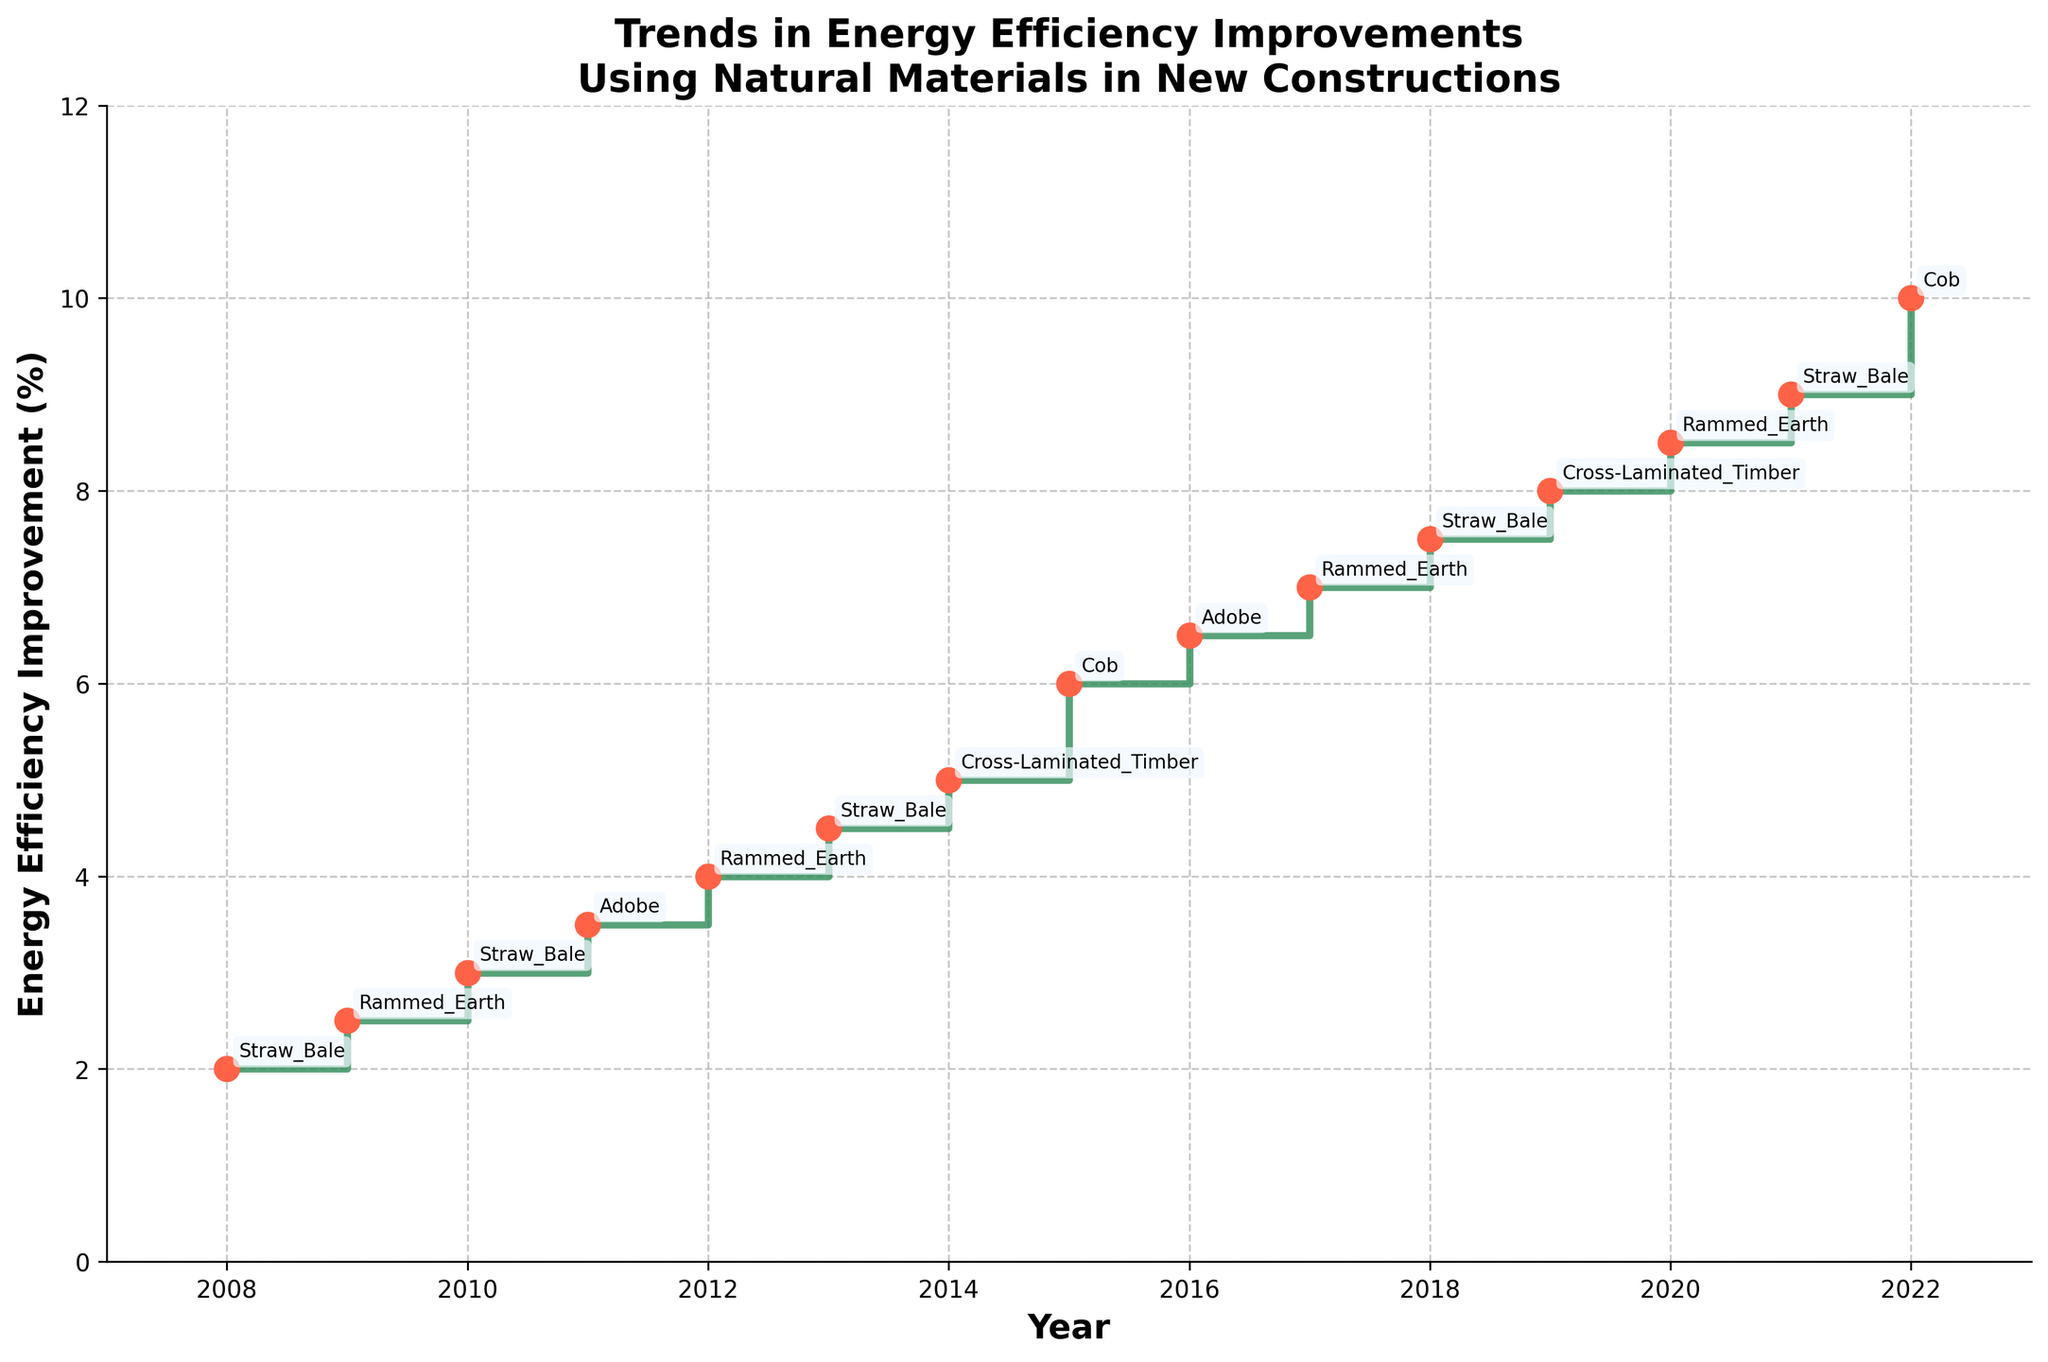How many data points are represented in the figure? There are data points for each year between 2008 and 2022 inclusive. Simply count the markers or the annotated years.
Answer: 15 What is the primary material used in 2016? Look at the annotation for the year 2016. It shows the primary material used.
Answer: Adobe Which year shows the highest percentage improvement in energy efficiency? Find the highest point on the y-axis and refer to the corresponding year on the x-axis.
Answer: 2022 What is the increase in energy efficiency from 2014 to 2015? Look at the energy efficiency values for 2014 and 2015. Subtract the 2014 value from the 2015 value. \( \text{6} - \text{5} = \text{1} \)
Answer: 1 % Between which two consecutive years did the energy efficiency improvement percentage increase the most? Calculate the differences between consecutive years and find the maximum value. The largest increase found is between 2018 and 2019 (8 - 7.5 = 0.5). The largest increase is actually between 2021 and 2022 (10 - 9 = 1).
Answer: 2021 and 2022 Which material was used most frequently throughout the 15 years? Count the frequencies of each material in the annotations. Straw Bale appears more often than other materials.
Answer: Straw Bale Was there any year when the same primary material was used consecutively? Check if the same material is mentioned in the annotations for consecutive years. There were no consecutive years with the same material.
Answer: No Compare the energy efficiency improvements in the years 2009 and 2012. Which year had a higher improvement and by how much? Compare the values of energy efficiency improvement for 2009 (2.5%) and 2012 (4%). Subtract the smaller value from the larger value. \( 4 - 2.5 = 1.5 \)
Answer: 2012 by 1.5 % What is the pattern of improvement in energy efficiency from 2008 to 2022? Observe the trend of the plotted line from year to year. The trend shows a generally steady increase in energy efficiency over the years.
Answer: Steady Increase In which year did Cross-Laminated Timber contribute to the highest energy efficiency improvement? Look for the points annotated with Cross-Laminated Timber and compare their y-axis values. The highest for Cross-Laminated Timber is in the year 2019.
Answer: 2019 